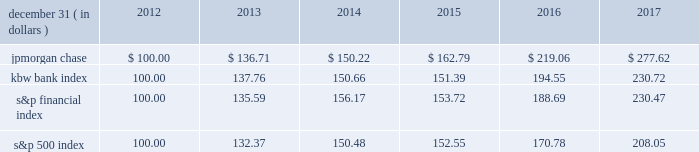Jpmorgan chase & co./2017 annual report 39 five-year stock performance the table and graph compare the five-year cumulative total return for jpmorgan chase & co .
( 201cjpmorgan chase 201d or the 201cfirm 201d ) common stock with the cumulative return of the s&p 500 index , the kbw bank index and the s&p financial index .
The s&p 500 index is a commonly referenced equity benchmark in the united states of america ( 201cu.s . 201d ) , consisting of leading companies from different economic sectors .
The kbw bank index seeks to reflect the performance of banks and thrifts that are publicly traded in the u.s .
And is composed of leading national money center and regional banks and thrifts .
The s&p financial index is an index of financial companies , all of which are components of the s&p 500 .
The firm is a component of all three industry indices .
The table and graph assume simultaneous investments of $ 100 on december 31 , 2012 , in jpmorgan chase common stock and in each of the above indices .
The comparison assumes that all dividends are reinvested .
December 31 , ( in dollars ) 2012 2013 2014 2015 2016 2017 .
December 31 , ( in dollars ) 201720162015201420132012 .
Did jpmorgan chase outperform the s&p 500 index?\\n? 
Computations: (277.62 > 208.05)
Answer: yes. Jpmorgan chase & co./2017 annual report 39 five-year stock performance the table and graph compare the five-year cumulative total return for jpmorgan chase & co .
( 201cjpmorgan chase 201d or the 201cfirm 201d ) common stock with the cumulative return of the s&p 500 index , the kbw bank index and the s&p financial index .
The s&p 500 index is a commonly referenced equity benchmark in the united states of america ( 201cu.s . 201d ) , consisting of leading companies from different economic sectors .
The kbw bank index seeks to reflect the performance of banks and thrifts that are publicly traded in the u.s .
And is composed of leading national money center and regional banks and thrifts .
The s&p financial index is an index of financial companies , all of which are components of the s&p 500 .
The firm is a component of all three industry indices .
The table and graph assume simultaneous investments of $ 100 on december 31 , 2012 , in jpmorgan chase common stock and in each of the above indices .
The comparison assumes that all dividends are reinvested .
December 31 , ( in dollars ) 2012 2013 2014 2015 2016 2017 .
December 31 , ( in dollars ) 201720162015201420132012 .
Did jpmorgan chase outperform the kbw bank index? 
Rationale: outperform = greater 5 year total return
Computations: (277.62 > 230.72)
Answer: yes. 